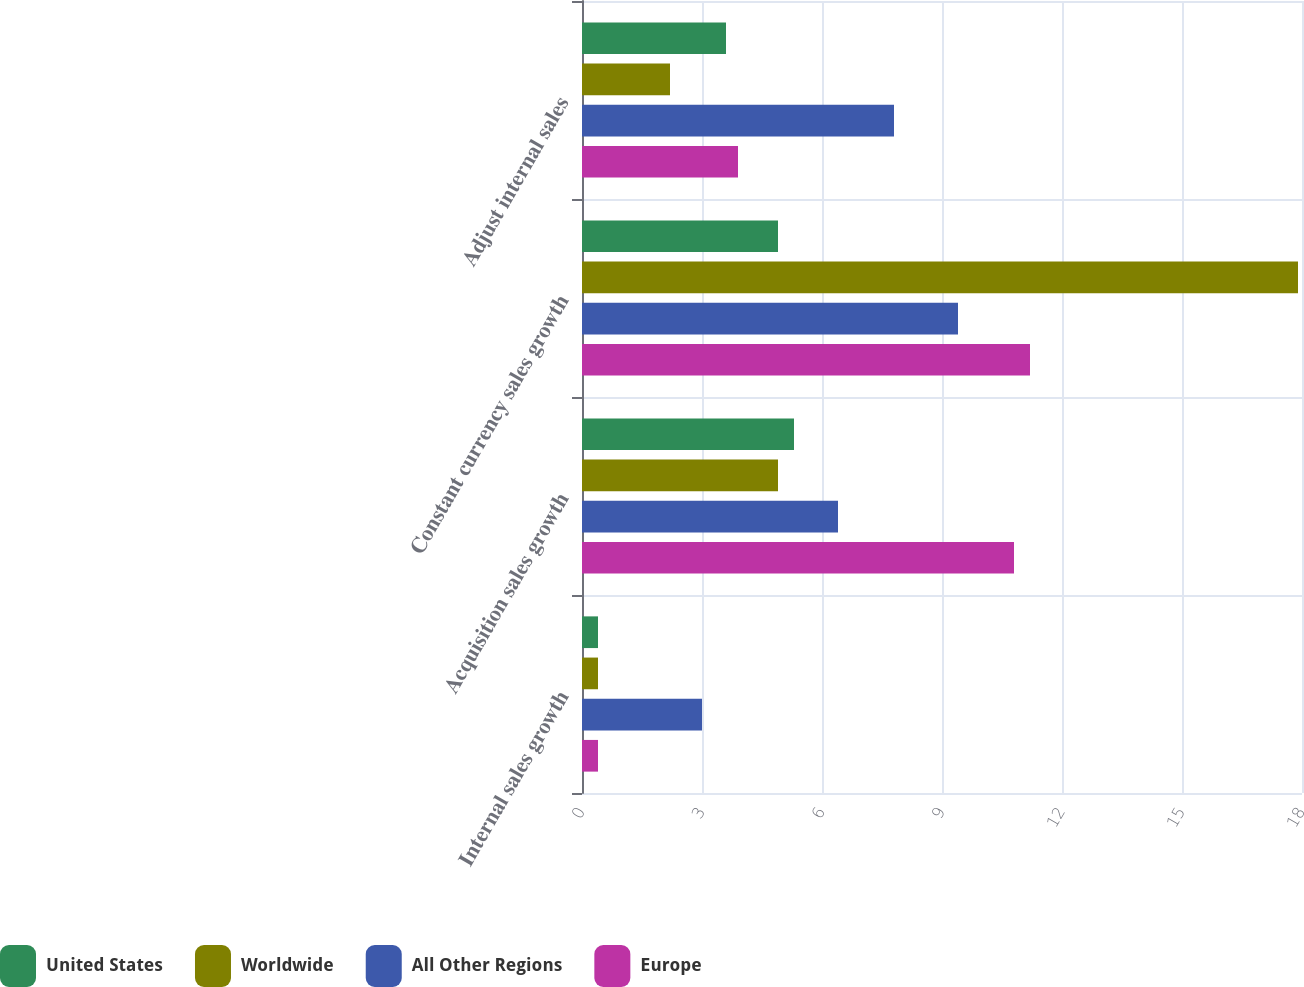Convert chart to OTSL. <chart><loc_0><loc_0><loc_500><loc_500><stacked_bar_chart><ecel><fcel>Internal sales growth<fcel>Acquisition sales growth<fcel>Constant currency sales growth<fcel>Adjust internal sales<nl><fcel>United States<fcel>0.4<fcel>5.3<fcel>4.9<fcel>3.6<nl><fcel>Worldwide<fcel>0.4<fcel>4.9<fcel>17.9<fcel>2.2<nl><fcel>All Other Regions<fcel>3<fcel>6.4<fcel>9.4<fcel>7.8<nl><fcel>Europe<fcel>0.4<fcel>10.8<fcel>11.2<fcel>3.9<nl></chart> 